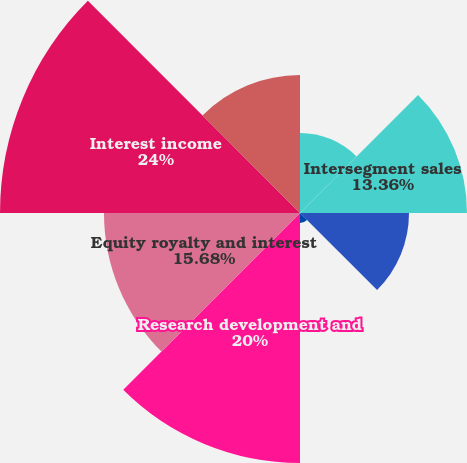Convert chart to OTSL. <chart><loc_0><loc_0><loc_500><loc_500><pie_chart><fcel>External sales<fcel>Intersegment sales<fcel>Total sales<fcel>Depreciation and amortization<fcel>Research development and<fcel>Equity royalty and interest<fcel>Interest income<fcel>Segment EBIT<nl><fcel>6.4%<fcel>13.36%<fcel>8.72%<fcel>0.8%<fcel>20.0%<fcel>15.68%<fcel>24.0%<fcel>11.04%<nl></chart> 